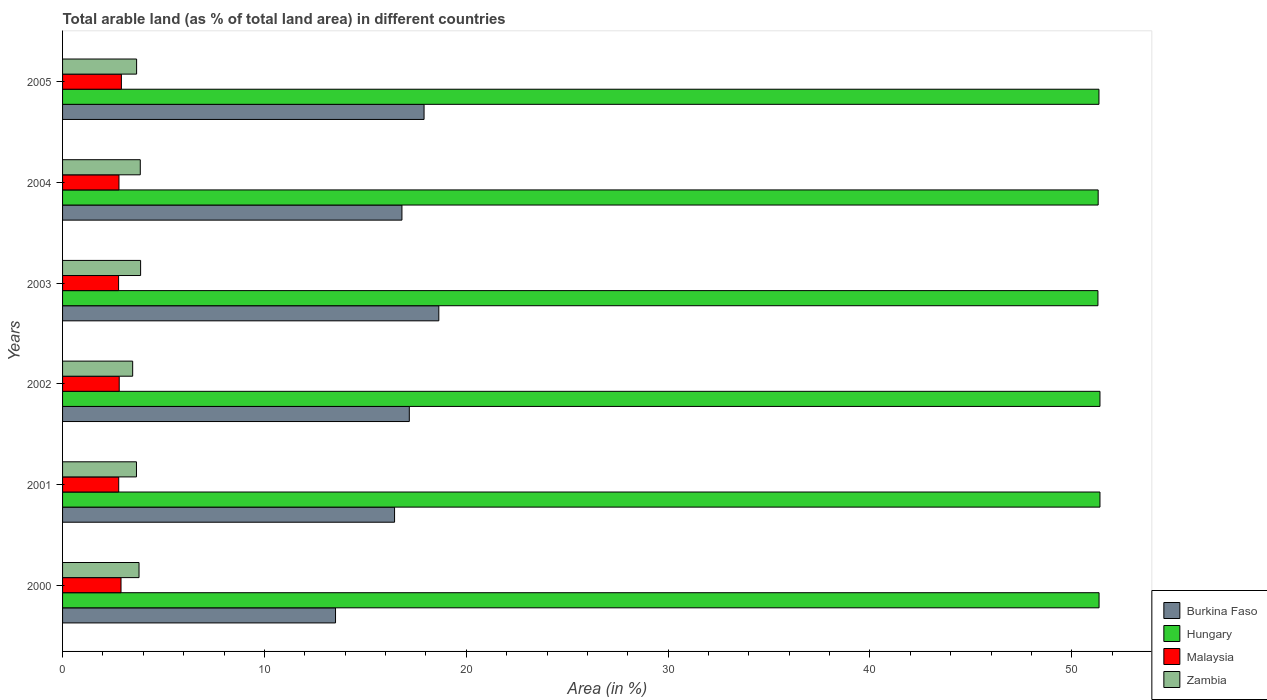How many different coloured bars are there?
Ensure brevity in your answer.  4. Are the number of bars on each tick of the Y-axis equal?
Make the answer very short. Yes. How many bars are there on the 4th tick from the top?
Keep it short and to the point. 4. What is the percentage of arable land in Malaysia in 2003?
Provide a short and direct response. 2.78. Across all years, what is the maximum percentage of arable land in Malaysia?
Keep it short and to the point. 2.91. Across all years, what is the minimum percentage of arable land in Malaysia?
Keep it short and to the point. 2.78. What is the total percentage of arable land in Hungary in the graph?
Offer a very short reply. 308.08. What is the difference between the percentage of arable land in Hungary in 2002 and that in 2004?
Ensure brevity in your answer.  0.09. What is the difference between the percentage of arable land in Malaysia in 2004 and the percentage of arable land in Burkina Faso in 2002?
Offer a very short reply. -14.38. What is the average percentage of arable land in Burkina Faso per year?
Ensure brevity in your answer.  16.75. In the year 2003, what is the difference between the percentage of arable land in Zambia and percentage of arable land in Hungary?
Your answer should be compact. -47.43. In how many years, is the percentage of arable land in Zambia greater than 4 %?
Your response must be concise. 0. What is the ratio of the percentage of arable land in Burkina Faso in 2001 to that in 2002?
Your answer should be very brief. 0.96. Is the percentage of arable land in Zambia in 2003 less than that in 2004?
Your response must be concise. No. Is the difference between the percentage of arable land in Zambia in 2004 and 2005 greater than the difference between the percentage of arable land in Hungary in 2004 and 2005?
Your response must be concise. Yes. What is the difference between the highest and the second highest percentage of arable land in Malaysia?
Make the answer very short. 0.02. What is the difference between the highest and the lowest percentage of arable land in Hungary?
Give a very brief answer. 0.1. In how many years, is the percentage of arable land in Hungary greater than the average percentage of arable land in Hungary taken over all years?
Make the answer very short. 3. Is it the case that in every year, the sum of the percentage of arable land in Malaysia and percentage of arable land in Burkina Faso is greater than the sum of percentage of arable land in Hungary and percentage of arable land in Zambia?
Ensure brevity in your answer.  No. What does the 3rd bar from the top in 2005 represents?
Provide a short and direct response. Hungary. What does the 4th bar from the bottom in 2004 represents?
Ensure brevity in your answer.  Zambia. Is it the case that in every year, the sum of the percentage of arable land in Burkina Faso and percentage of arable land in Hungary is greater than the percentage of arable land in Zambia?
Make the answer very short. Yes. How many bars are there?
Ensure brevity in your answer.  24. Are all the bars in the graph horizontal?
Your answer should be very brief. Yes. Does the graph contain any zero values?
Make the answer very short. No. How many legend labels are there?
Offer a terse response. 4. How are the legend labels stacked?
Offer a very short reply. Vertical. What is the title of the graph?
Offer a terse response. Total arable land (as % of total land area) in different countries. What is the label or title of the X-axis?
Provide a succinct answer. Area (in %). What is the Area (in %) in Burkina Faso in 2000?
Your response must be concise. 13.52. What is the Area (in %) of Hungary in 2000?
Your answer should be very brief. 51.35. What is the Area (in %) of Malaysia in 2000?
Offer a terse response. 2.9. What is the Area (in %) in Zambia in 2000?
Offer a very short reply. 3.79. What is the Area (in %) in Burkina Faso in 2001?
Your response must be concise. 16.45. What is the Area (in %) in Hungary in 2001?
Offer a terse response. 51.39. What is the Area (in %) in Malaysia in 2001?
Offer a very short reply. 2.78. What is the Area (in %) of Zambia in 2001?
Offer a terse response. 3.66. What is the Area (in %) in Burkina Faso in 2002?
Your response must be concise. 17.18. What is the Area (in %) in Hungary in 2002?
Your answer should be compact. 51.39. What is the Area (in %) of Malaysia in 2002?
Provide a succinct answer. 2.81. What is the Area (in %) in Zambia in 2002?
Keep it short and to the point. 3.47. What is the Area (in %) in Burkina Faso in 2003?
Offer a terse response. 18.64. What is the Area (in %) in Hungary in 2003?
Provide a short and direct response. 51.29. What is the Area (in %) of Malaysia in 2003?
Offer a terse response. 2.78. What is the Area (in %) of Zambia in 2003?
Offer a very short reply. 3.87. What is the Area (in %) in Burkina Faso in 2004?
Keep it short and to the point. 16.81. What is the Area (in %) in Hungary in 2004?
Provide a succinct answer. 51.31. What is the Area (in %) of Malaysia in 2004?
Offer a very short reply. 2.79. What is the Area (in %) in Zambia in 2004?
Keep it short and to the point. 3.85. What is the Area (in %) in Burkina Faso in 2005?
Keep it short and to the point. 17.91. What is the Area (in %) of Hungary in 2005?
Keep it short and to the point. 51.34. What is the Area (in %) of Malaysia in 2005?
Keep it short and to the point. 2.91. What is the Area (in %) of Zambia in 2005?
Your response must be concise. 3.67. Across all years, what is the maximum Area (in %) in Burkina Faso?
Provide a short and direct response. 18.64. Across all years, what is the maximum Area (in %) in Hungary?
Keep it short and to the point. 51.39. Across all years, what is the maximum Area (in %) in Malaysia?
Provide a short and direct response. 2.91. Across all years, what is the maximum Area (in %) in Zambia?
Ensure brevity in your answer.  3.87. Across all years, what is the minimum Area (in %) in Burkina Faso?
Make the answer very short. 13.52. Across all years, what is the minimum Area (in %) of Hungary?
Provide a short and direct response. 51.29. Across all years, what is the minimum Area (in %) of Malaysia?
Your answer should be compact. 2.78. Across all years, what is the minimum Area (in %) of Zambia?
Offer a terse response. 3.47. What is the total Area (in %) of Burkina Faso in the graph?
Provide a short and direct response. 100.51. What is the total Area (in %) of Hungary in the graph?
Provide a short and direct response. 308.08. What is the total Area (in %) in Malaysia in the graph?
Offer a very short reply. 16.97. What is the total Area (in %) of Zambia in the graph?
Ensure brevity in your answer.  22.31. What is the difference between the Area (in %) in Burkina Faso in 2000 and that in 2001?
Your response must be concise. -2.92. What is the difference between the Area (in %) of Hungary in 2000 and that in 2001?
Give a very brief answer. -0.04. What is the difference between the Area (in %) in Malaysia in 2000 and that in 2001?
Your answer should be very brief. 0.11. What is the difference between the Area (in %) in Zambia in 2000 and that in 2001?
Your answer should be compact. 0.13. What is the difference between the Area (in %) of Burkina Faso in 2000 and that in 2002?
Your answer should be very brief. -3.65. What is the difference between the Area (in %) of Hungary in 2000 and that in 2002?
Your response must be concise. -0.04. What is the difference between the Area (in %) in Malaysia in 2000 and that in 2002?
Your answer should be very brief. 0.09. What is the difference between the Area (in %) in Zambia in 2000 and that in 2002?
Make the answer very short. 0.31. What is the difference between the Area (in %) in Burkina Faso in 2000 and that in 2003?
Offer a terse response. -5.12. What is the difference between the Area (in %) in Hungary in 2000 and that in 2003?
Provide a short and direct response. 0.06. What is the difference between the Area (in %) of Malaysia in 2000 and that in 2003?
Offer a terse response. 0.12. What is the difference between the Area (in %) in Zambia in 2000 and that in 2003?
Provide a succinct answer. -0.08. What is the difference between the Area (in %) in Burkina Faso in 2000 and that in 2004?
Your response must be concise. -3.29. What is the difference between the Area (in %) of Hungary in 2000 and that in 2004?
Ensure brevity in your answer.  0.04. What is the difference between the Area (in %) in Malaysia in 2000 and that in 2004?
Offer a very short reply. 0.1. What is the difference between the Area (in %) in Zambia in 2000 and that in 2004?
Provide a short and direct response. -0.06. What is the difference between the Area (in %) in Burkina Faso in 2000 and that in 2005?
Keep it short and to the point. -4.39. What is the difference between the Area (in %) of Hungary in 2000 and that in 2005?
Offer a very short reply. 0.01. What is the difference between the Area (in %) in Malaysia in 2000 and that in 2005?
Offer a terse response. -0.02. What is the difference between the Area (in %) in Zambia in 2000 and that in 2005?
Provide a succinct answer. 0.12. What is the difference between the Area (in %) in Burkina Faso in 2001 and that in 2002?
Make the answer very short. -0.73. What is the difference between the Area (in %) in Malaysia in 2001 and that in 2002?
Keep it short and to the point. -0.03. What is the difference between the Area (in %) in Zambia in 2001 and that in 2002?
Provide a short and direct response. 0.19. What is the difference between the Area (in %) in Burkina Faso in 2001 and that in 2003?
Provide a succinct answer. -2.19. What is the difference between the Area (in %) in Hungary in 2001 and that in 2003?
Give a very brief answer. 0.1. What is the difference between the Area (in %) in Malaysia in 2001 and that in 2003?
Your answer should be very brief. 0.01. What is the difference between the Area (in %) in Zambia in 2001 and that in 2003?
Provide a short and direct response. -0.2. What is the difference between the Area (in %) of Burkina Faso in 2001 and that in 2004?
Your response must be concise. -0.37. What is the difference between the Area (in %) of Hungary in 2001 and that in 2004?
Your answer should be very brief. 0.09. What is the difference between the Area (in %) in Malaysia in 2001 and that in 2004?
Make the answer very short. -0.01. What is the difference between the Area (in %) in Zambia in 2001 and that in 2004?
Ensure brevity in your answer.  -0.19. What is the difference between the Area (in %) of Burkina Faso in 2001 and that in 2005?
Offer a terse response. -1.46. What is the difference between the Area (in %) of Hungary in 2001 and that in 2005?
Provide a succinct answer. 0.05. What is the difference between the Area (in %) in Malaysia in 2001 and that in 2005?
Offer a very short reply. -0.13. What is the difference between the Area (in %) in Zambia in 2001 and that in 2005?
Keep it short and to the point. -0.01. What is the difference between the Area (in %) in Burkina Faso in 2002 and that in 2003?
Keep it short and to the point. -1.46. What is the difference between the Area (in %) in Hungary in 2002 and that in 2003?
Ensure brevity in your answer.  0.1. What is the difference between the Area (in %) of Malaysia in 2002 and that in 2003?
Give a very brief answer. 0.03. What is the difference between the Area (in %) of Zambia in 2002 and that in 2003?
Your answer should be very brief. -0.39. What is the difference between the Area (in %) in Burkina Faso in 2002 and that in 2004?
Your response must be concise. 0.37. What is the difference between the Area (in %) of Hungary in 2002 and that in 2004?
Ensure brevity in your answer.  0.09. What is the difference between the Area (in %) in Malaysia in 2002 and that in 2004?
Your response must be concise. 0.01. What is the difference between the Area (in %) in Zambia in 2002 and that in 2004?
Give a very brief answer. -0.38. What is the difference between the Area (in %) of Burkina Faso in 2002 and that in 2005?
Your answer should be compact. -0.73. What is the difference between the Area (in %) of Hungary in 2002 and that in 2005?
Make the answer very short. 0.05. What is the difference between the Area (in %) of Malaysia in 2002 and that in 2005?
Make the answer very short. -0.11. What is the difference between the Area (in %) in Zambia in 2002 and that in 2005?
Offer a very short reply. -0.2. What is the difference between the Area (in %) of Burkina Faso in 2003 and that in 2004?
Your response must be concise. 1.83. What is the difference between the Area (in %) in Hungary in 2003 and that in 2004?
Your answer should be very brief. -0.01. What is the difference between the Area (in %) of Malaysia in 2003 and that in 2004?
Offer a terse response. -0.02. What is the difference between the Area (in %) in Zambia in 2003 and that in 2004?
Keep it short and to the point. 0.02. What is the difference between the Area (in %) of Burkina Faso in 2003 and that in 2005?
Your response must be concise. 0.73. What is the difference between the Area (in %) of Hungary in 2003 and that in 2005?
Provide a short and direct response. -0.05. What is the difference between the Area (in %) of Malaysia in 2003 and that in 2005?
Provide a short and direct response. -0.14. What is the difference between the Area (in %) in Zambia in 2003 and that in 2005?
Your answer should be very brief. 0.2. What is the difference between the Area (in %) in Burkina Faso in 2004 and that in 2005?
Offer a very short reply. -1.1. What is the difference between the Area (in %) in Hungary in 2004 and that in 2005?
Your answer should be very brief. -0.04. What is the difference between the Area (in %) in Malaysia in 2004 and that in 2005?
Offer a very short reply. -0.12. What is the difference between the Area (in %) in Zambia in 2004 and that in 2005?
Make the answer very short. 0.18. What is the difference between the Area (in %) of Burkina Faso in 2000 and the Area (in %) of Hungary in 2001?
Provide a short and direct response. -37.87. What is the difference between the Area (in %) in Burkina Faso in 2000 and the Area (in %) in Malaysia in 2001?
Your answer should be compact. 10.74. What is the difference between the Area (in %) in Burkina Faso in 2000 and the Area (in %) in Zambia in 2001?
Offer a terse response. 9.86. What is the difference between the Area (in %) of Hungary in 2000 and the Area (in %) of Malaysia in 2001?
Give a very brief answer. 48.57. What is the difference between the Area (in %) of Hungary in 2000 and the Area (in %) of Zambia in 2001?
Give a very brief answer. 47.69. What is the difference between the Area (in %) in Malaysia in 2000 and the Area (in %) in Zambia in 2001?
Give a very brief answer. -0.77. What is the difference between the Area (in %) in Burkina Faso in 2000 and the Area (in %) in Hungary in 2002?
Your answer should be very brief. -37.87. What is the difference between the Area (in %) of Burkina Faso in 2000 and the Area (in %) of Malaysia in 2002?
Provide a succinct answer. 10.72. What is the difference between the Area (in %) in Burkina Faso in 2000 and the Area (in %) in Zambia in 2002?
Provide a short and direct response. 10.05. What is the difference between the Area (in %) in Hungary in 2000 and the Area (in %) in Malaysia in 2002?
Your answer should be compact. 48.54. What is the difference between the Area (in %) of Hungary in 2000 and the Area (in %) of Zambia in 2002?
Ensure brevity in your answer.  47.88. What is the difference between the Area (in %) of Malaysia in 2000 and the Area (in %) of Zambia in 2002?
Give a very brief answer. -0.58. What is the difference between the Area (in %) in Burkina Faso in 2000 and the Area (in %) in Hungary in 2003?
Make the answer very short. -37.77. What is the difference between the Area (in %) of Burkina Faso in 2000 and the Area (in %) of Malaysia in 2003?
Give a very brief answer. 10.75. What is the difference between the Area (in %) of Burkina Faso in 2000 and the Area (in %) of Zambia in 2003?
Make the answer very short. 9.66. What is the difference between the Area (in %) of Hungary in 2000 and the Area (in %) of Malaysia in 2003?
Ensure brevity in your answer.  48.57. What is the difference between the Area (in %) in Hungary in 2000 and the Area (in %) in Zambia in 2003?
Your answer should be compact. 47.48. What is the difference between the Area (in %) in Malaysia in 2000 and the Area (in %) in Zambia in 2003?
Provide a short and direct response. -0.97. What is the difference between the Area (in %) of Burkina Faso in 2000 and the Area (in %) of Hungary in 2004?
Provide a short and direct response. -37.78. What is the difference between the Area (in %) of Burkina Faso in 2000 and the Area (in %) of Malaysia in 2004?
Provide a short and direct response. 10.73. What is the difference between the Area (in %) of Burkina Faso in 2000 and the Area (in %) of Zambia in 2004?
Give a very brief answer. 9.67. What is the difference between the Area (in %) of Hungary in 2000 and the Area (in %) of Malaysia in 2004?
Your answer should be very brief. 48.56. What is the difference between the Area (in %) in Hungary in 2000 and the Area (in %) in Zambia in 2004?
Offer a terse response. 47.5. What is the difference between the Area (in %) of Malaysia in 2000 and the Area (in %) of Zambia in 2004?
Your answer should be very brief. -0.95. What is the difference between the Area (in %) of Burkina Faso in 2000 and the Area (in %) of Hungary in 2005?
Make the answer very short. -37.82. What is the difference between the Area (in %) of Burkina Faso in 2000 and the Area (in %) of Malaysia in 2005?
Provide a short and direct response. 10.61. What is the difference between the Area (in %) in Burkina Faso in 2000 and the Area (in %) in Zambia in 2005?
Keep it short and to the point. 9.86. What is the difference between the Area (in %) in Hungary in 2000 and the Area (in %) in Malaysia in 2005?
Provide a short and direct response. 48.44. What is the difference between the Area (in %) of Hungary in 2000 and the Area (in %) of Zambia in 2005?
Your answer should be very brief. 47.68. What is the difference between the Area (in %) in Malaysia in 2000 and the Area (in %) in Zambia in 2005?
Ensure brevity in your answer.  -0.77. What is the difference between the Area (in %) of Burkina Faso in 2001 and the Area (in %) of Hungary in 2002?
Your answer should be compact. -34.95. What is the difference between the Area (in %) in Burkina Faso in 2001 and the Area (in %) in Malaysia in 2002?
Your answer should be very brief. 13.64. What is the difference between the Area (in %) of Burkina Faso in 2001 and the Area (in %) of Zambia in 2002?
Offer a terse response. 12.97. What is the difference between the Area (in %) in Hungary in 2001 and the Area (in %) in Malaysia in 2002?
Provide a short and direct response. 48.59. What is the difference between the Area (in %) of Hungary in 2001 and the Area (in %) of Zambia in 2002?
Offer a very short reply. 47.92. What is the difference between the Area (in %) in Malaysia in 2001 and the Area (in %) in Zambia in 2002?
Your answer should be compact. -0.69. What is the difference between the Area (in %) of Burkina Faso in 2001 and the Area (in %) of Hungary in 2003?
Offer a terse response. -34.85. What is the difference between the Area (in %) in Burkina Faso in 2001 and the Area (in %) in Malaysia in 2003?
Provide a succinct answer. 13.67. What is the difference between the Area (in %) in Burkina Faso in 2001 and the Area (in %) in Zambia in 2003?
Keep it short and to the point. 12.58. What is the difference between the Area (in %) in Hungary in 2001 and the Area (in %) in Malaysia in 2003?
Provide a short and direct response. 48.62. What is the difference between the Area (in %) of Hungary in 2001 and the Area (in %) of Zambia in 2003?
Offer a very short reply. 47.53. What is the difference between the Area (in %) of Malaysia in 2001 and the Area (in %) of Zambia in 2003?
Make the answer very short. -1.08. What is the difference between the Area (in %) in Burkina Faso in 2001 and the Area (in %) in Hungary in 2004?
Offer a very short reply. -34.86. What is the difference between the Area (in %) of Burkina Faso in 2001 and the Area (in %) of Malaysia in 2004?
Keep it short and to the point. 13.65. What is the difference between the Area (in %) of Burkina Faso in 2001 and the Area (in %) of Zambia in 2004?
Your response must be concise. 12.6. What is the difference between the Area (in %) in Hungary in 2001 and the Area (in %) in Malaysia in 2004?
Keep it short and to the point. 48.6. What is the difference between the Area (in %) in Hungary in 2001 and the Area (in %) in Zambia in 2004?
Provide a short and direct response. 47.54. What is the difference between the Area (in %) in Malaysia in 2001 and the Area (in %) in Zambia in 2004?
Make the answer very short. -1.07. What is the difference between the Area (in %) in Burkina Faso in 2001 and the Area (in %) in Hungary in 2005?
Your answer should be compact. -34.9. What is the difference between the Area (in %) of Burkina Faso in 2001 and the Area (in %) of Malaysia in 2005?
Offer a very short reply. 13.53. What is the difference between the Area (in %) of Burkina Faso in 2001 and the Area (in %) of Zambia in 2005?
Offer a terse response. 12.78. What is the difference between the Area (in %) of Hungary in 2001 and the Area (in %) of Malaysia in 2005?
Provide a succinct answer. 48.48. What is the difference between the Area (in %) of Hungary in 2001 and the Area (in %) of Zambia in 2005?
Give a very brief answer. 47.73. What is the difference between the Area (in %) in Malaysia in 2001 and the Area (in %) in Zambia in 2005?
Make the answer very short. -0.89. What is the difference between the Area (in %) in Burkina Faso in 2002 and the Area (in %) in Hungary in 2003?
Provide a succinct answer. -34.12. What is the difference between the Area (in %) in Burkina Faso in 2002 and the Area (in %) in Malaysia in 2003?
Make the answer very short. 14.4. What is the difference between the Area (in %) of Burkina Faso in 2002 and the Area (in %) of Zambia in 2003?
Your response must be concise. 13.31. What is the difference between the Area (in %) of Hungary in 2002 and the Area (in %) of Malaysia in 2003?
Give a very brief answer. 48.62. What is the difference between the Area (in %) in Hungary in 2002 and the Area (in %) in Zambia in 2003?
Provide a succinct answer. 47.53. What is the difference between the Area (in %) of Malaysia in 2002 and the Area (in %) of Zambia in 2003?
Provide a succinct answer. -1.06. What is the difference between the Area (in %) of Burkina Faso in 2002 and the Area (in %) of Hungary in 2004?
Give a very brief answer. -34.13. What is the difference between the Area (in %) of Burkina Faso in 2002 and the Area (in %) of Malaysia in 2004?
Keep it short and to the point. 14.38. What is the difference between the Area (in %) in Burkina Faso in 2002 and the Area (in %) in Zambia in 2004?
Give a very brief answer. 13.33. What is the difference between the Area (in %) of Hungary in 2002 and the Area (in %) of Malaysia in 2004?
Offer a terse response. 48.6. What is the difference between the Area (in %) in Hungary in 2002 and the Area (in %) in Zambia in 2004?
Give a very brief answer. 47.54. What is the difference between the Area (in %) in Malaysia in 2002 and the Area (in %) in Zambia in 2004?
Give a very brief answer. -1.04. What is the difference between the Area (in %) of Burkina Faso in 2002 and the Area (in %) of Hungary in 2005?
Your answer should be compact. -34.17. What is the difference between the Area (in %) of Burkina Faso in 2002 and the Area (in %) of Malaysia in 2005?
Offer a very short reply. 14.26. What is the difference between the Area (in %) of Burkina Faso in 2002 and the Area (in %) of Zambia in 2005?
Your answer should be compact. 13.51. What is the difference between the Area (in %) of Hungary in 2002 and the Area (in %) of Malaysia in 2005?
Ensure brevity in your answer.  48.48. What is the difference between the Area (in %) in Hungary in 2002 and the Area (in %) in Zambia in 2005?
Your answer should be compact. 47.73. What is the difference between the Area (in %) in Malaysia in 2002 and the Area (in %) in Zambia in 2005?
Make the answer very short. -0.86. What is the difference between the Area (in %) in Burkina Faso in 2003 and the Area (in %) in Hungary in 2004?
Provide a succinct answer. -32.67. What is the difference between the Area (in %) in Burkina Faso in 2003 and the Area (in %) in Malaysia in 2004?
Your response must be concise. 15.85. What is the difference between the Area (in %) in Burkina Faso in 2003 and the Area (in %) in Zambia in 2004?
Make the answer very short. 14.79. What is the difference between the Area (in %) in Hungary in 2003 and the Area (in %) in Malaysia in 2004?
Make the answer very short. 48.5. What is the difference between the Area (in %) in Hungary in 2003 and the Area (in %) in Zambia in 2004?
Provide a short and direct response. 47.44. What is the difference between the Area (in %) of Malaysia in 2003 and the Area (in %) of Zambia in 2004?
Offer a very short reply. -1.07. What is the difference between the Area (in %) of Burkina Faso in 2003 and the Area (in %) of Hungary in 2005?
Provide a short and direct response. -32.7. What is the difference between the Area (in %) of Burkina Faso in 2003 and the Area (in %) of Malaysia in 2005?
Offer a very short reply. 15.73. What is the difference between the Area (in %) in Burkina Faso in 2003 and the Area (in %) in Zambia in 2005?
Provide a succinct answer. 14.97. What is the difference between the Area (in %) in Hungary in 2003 and the Area (in %) in Malaysia in 2005?
Offer a terse response. 48.38. What is the difference between the Area (in %) of Hungary in 2003 and the Area (in %) of Zambia in 2005?
Your answer should be very brief. 47.63. What is the difference between the Area (in %) of Malaysia in 2003 and the Area (in %) of Zambia in 2005?
Keep it short and to the point. -0.89. What is the difference between the Area (in %) in Burkina Faso in 2004 and the Area (in %) in Hungary in 2005?
Keep it short and to the point. -34.53. What is the difference between the Area (in %) of Burkina Faso in 2004 and the Area (in %) of Malaysia in 2005?
Offer a terse response. 13.9. What is the difference between the Area (in %) of Burkina Faso in 2004 and the Area (in %) of Zambia in 2005?
Make the answer very short. 13.14. What is the difference between the Area (in %) in Hungary in 2004 and the Area (in %) in Malaysia in 2005?
Make the answer very short. 48.39. What is the difference between the Area (in %) of Hungary in 2004 and the Area (in %) of Zambia in 2005?
Offer a very short reply. 47.64. What is the difference between the Area (in %) in Malaysia in 2004 and the Area (in %) in Zambia in 2005?
Offer a very short reply. -0.87. What is the average Area (in %) of Burkina Faso per year?
Give a very brief answer. 16.75. What is the average Area (in %) in Hungary per year?
Your answer should be very brief. 51.35. What is the average Area (in %) in Malaysia per year?
Ensure brevity in your answer.  2.83. What is the average Area (in %) in Zambia per year?
Provide a succinct answer. 3.72. In the year 2000, what is the difference between the Area (in %) of Burkina Faso and Area (in %) of Hungary?
Keep it short and to the point. -37.83. In the year 2000, what is the difference between the Area (in %) of Burkina Faso and Area (in %) of Malaysia?
Give a very brief answer. 10.63. In the year 2000, what is the difference between the Area (in %) in Burkina Faso and Area (in %) in Zambia?
Your answer should be compact. 9.74. In the year 2000, what is the difference between the Area (in %) in Hungary and Area (in %) in Malaysia?
Provide a succinct answer. 48.45. In the year 2000, what is the difference between the Area (in %) of Hungary and Area (in %) of Zambia?
Give a very brief answer. 47.56. In the year 2000, what is the difference between the Area (in %) in Malaysia and Area (in %) in Zambia?
Provide a short and direct response. -0.89. In the year 2001, what is the difference between the Area (in %) in Burkina Faso and Area (in %) in Hungary?
Ensure brevity in your answer.  -34.95. In the year 2001, what is the difference between the Area (in %) in Burkina Faso and Area (in %) in Malaysia?
Your response must be concise. 13.67. In the year 2001, what is the difference between the Area (in %) of Burkina Faso and Area (in %) of Zambia?
Offer a terse response. 12.79. In the year 2001, what is the difference between the Area (in %) in Hungary and Area (in %) in Malaysia?
Offer a very short reply. 48.61. In the year 2001, what is the difference between the Area (in %) of Hungary and Area (in %) of Zambia?
Your answer should be compact. 47.73. In the year 2001, what is the difference between the Area (in %) of Malaysia and Area (in %) of Zambia?
Your response must be concise. -0.88. In the year 2002, what is the difference between the Area (in %) of Burkina Faso and Area (in %) of Hungary?
Keep it short and to the point. -34.22. In the year 2002, what is the difference between the Area (in %) in Burkina Faso and Area (in %) in Malaysia?
Give a very brief answer. 14.37. In the year 2002, what is the difference between the Area (in %) in Burkina Faso and Area (in %) in Zambia?
Ensure brevity in your answer.  13.71. In the year 2002, what is the difference between the Area (in %) in Hungary and Area (in %) in Malaysia?
Offer a very short reply. 48.59. In the year 2002, what is the difference between the Area (in %) of Hungary and Area (in %) of Zambia?
Provide a succinct answer. 47.92. In the year 2002, what is the difference between the Area (in %) of Malaysia and Area (in %) of Zambia?
Offer a very short reply. -0.67. In the year 2003, what is the difference between the Area (in %) of Burkina Faso and Area (in %) of Hungary?
Keep it short and to the point. -32.65. In the year 2003, what is the difference between the Area (in %) of Burkina Faso and Area (in %) of Malaysia?
Ensure brevity in your answer.  15.86. In the year 2003, what is the difference between the Area (in %) in Burkina Faso and Area (in %) in Zambia?
Your response must be concise. 14.77. In the year 2003, what is the difference between the Area (in %) of Hungary and Area (in %) of Malaysia?
Keep it short and to the point. 48.52. In the year 2003, what is the difference between the Area (in %) of Hungary and Area (in %) of Zambia?
Your response must be concise. 47.43. In the year 2003, what is the difference between the Area (in %) in Malaysia and Area (in %) in Zambia?
Your answer should be compact. -1.09. In the year 2004, what is the difference between the Area (in %) in Burkina Faso and Area (in %) in Hungary?
Ensure brevity in your answer.  -34.49. In the year 2004, what is the difference between the Area (in %) of Burkina Faso and Area (in %) of Malaysia?
Provide a succinct answer. 14.02. In the year 2004, what is the difference between the Area (in %) of Burkina Faso and Area (in %) of Zambia?
Provide a short and direct response. 12.96. In the year 2004, what is the difference between the Area (in %) in Hungary and Area (in %) in Malaysia?
Offer a terse response. 48.51. In the year 2004, what is the difference between the Area (in %) in Hungary and Area (in %) in Zambia?
Keep it short and to the point. 47.46. In the year 2004, what is the difference between the Area (in %) of Malaysia and Area (in %) of Zambia?
Provide a succinct answer. -1.06. In the year 2005, what is the difference between the Area (in %) of Burkina Faso and Area (in %) of Hungary?
Your answer should be very brief. -33.44. In the year 2005, what is the difference between the Area (in %) of Burkina Faso and Area (in %) of Malaysia?
Ensure brevity in your answer.  14.99. In the year 2005, what is the difference between the Area (in %) in Burkina Faso and Area (in %) in Zambia?
Offer a terse response. 14.24. In the year 2005, what is the difference between the Area (in %) in Hungary and Area (in %) in Malaysia?
Keep it short and to the point. 48.43. In the year 2005, what is the difference between the Area (in %) of Hungary and Area (in %) of Zambia?
Your response must be concise. 47.68. In the year 2005, what is the difference between the Area (in %) in Malaysia and Area (in %) in Zambia?
Your answer should be compact. -0.75. What is the ratio of the Area (in %) of Burkina Faso in 2000 to that in 2001?
Your response must be concise. 0.82. What is the ratio of the Area (in %) in Hungary in 2000 to that in 2001?
Offer a terse response. 1. What is the ratio of the Area (in %) in Malaysia in 2000 to that in 2001?
Keep it short and to the point. 1.04. What is the ratio of the Area (in %) of Zambia in 2000 to that in 2001?
Provide a succinct answer. 1.03. What is the ratio of the Area (in %) of Burkina Faso in 2000 to that in 2002?
Provide a succinct answer. 0.79. What is the ratio of the Area (in %) in Malaysia in 2000 to that in 2002?
Your response must be concise. 1.03. What is the ratio of the Area (in %) in Zambia in 2000 to that in 2002?
Your answer should be very brief. 1.09. What is the ratio of the Area (in %) of Burkina Faso in 2000 to that in 2003?
Give a very brief answer. 0.73. What is the ratio of the Area (in %) of Malaysia in 2000 to that in 2003?
Keep it short and to the point. 1.04. What is the ratio of the Area (in %) of Zambia in 2000 to that in 2003?
Make the answer very short. 0.98. What is the ratio of the Area (in %) in Burkina Faso in 2000 to that in 2004?
Make the answer very short. 0.8. What is the ratio of the Area (in %) in Malaysia in 2000 to that in 2004?
Your response must be concise. 1.04. What is the ratio of the Area (in %) of Zambia in 2000 to that in 2004?
Make the answer very short. 0.98. What is the ratio of the Area (in %) of Burkina Faso in 2000 to that in 2005?
Your response must be concise. 0.76. What is the ratio of the Area (in %) of Zambia in 2000 to that in 2005?
Make the answer very short. 1.03. What is the ratio of the Area (in %) in Burkina Faso in 2001 to that in 2002?
Provide a succinct answer. 0.96. What is the ratio of the Area (in %) in Hungary in 2001 to that in 2002?
Your answer should be compact. 1. What is the ratio of the Area (in %) in Malaysia in 2001 to that in 2002?
Make the answer very short. 0.99. What is the ratio of the Area (in %) in Zambia in 2001 to that in 2002?
Provide a succinct answer. 1.05. What is the ratio of the Area (in %) in Burkina Faso in 2001 to that in 2003?
Your answer should be compact. 0.88. What is the ratio of the Area (in %) in Hungary in 2001 to that in 2003?
Ensure brevity in your answer.  1. What is the ratio of the Area (in %) of Malaysia in 2001 to that in 2003?
Your answer should be compact. 1. What is the ratio of the Area (in %) in Zambia in 2001 to that in 2003?
Your answer should be compact. 0.95. What is the ratio of the Area (in %) in Burkina Faso in 2001 to that in 2004?
Your response must be concise. 0.98. What is the ratio of the Area (in %) of Hungary in 2001 to that in 2004?
Your response must be concise. 1. What is the ratio of the Area (in %) of Zambia in 2001 to that in 2004?
Keep it short and to the point. 0.95. What is the ratio of the Area (in %) in Burkina Faso in 2001 to that in 2005?
Offer a very short reply. 0.92. What is the ratio of the Area (in %) of Hungary in 2001 to that in 2005?
Offer a very short reply. 1. What is the ratio of the Area (in %) of Malaysia in 2001 to that in 2005?
Offer a very short reply. 0.95. What is the ratio of the Area (in %) of Burkina Faso in 2002 to that in 2003?
Your response must be concise. 0.92. What is the ratio of the Area (in %) of Malaysia in 2002 to that in 2003?
Your answer should be compact. 1.01. What is the ratio of the Area (in %) of Zambia in 2002 to that in 2003?
Offer a terse response. 0.9. What is the ratio of the Area (in %) in Burkina Faso in 2002 to that in 2004?
Your response must be concise. 1.02. What is the ratio of the Area (in %) of Hungary in 2002 to that in 2004?
Give a very brief answer. 1. What is the ratio of the Area (in %) of Malaysia in 2002 to that in 2004?
Your answer should be compact. 1. What is the ratio of the Area (in %) of Zambia in 2002 to that in 2004?
Your response must be concise. 0.9. What is the ratio of the Area (in %) of Burkina Faso in 2002 to that in 2005?
Ensure brevity in your answer.  0.96. What is the ratio of the Area (in %) of Hungary in 2002 to that in 2005?
Your answer should be compact. 1. What is the ratio of the Area (in %) in Malaysia in 2002 to that in 2005?
Make the answer very short. 0.96. What is the ratio of the Area (in %) of Zambia in 2002 to that in 2005?
Provide a short and direct response. 0.95. What is the ratio of the Area (in %) of Burkina Faso in 2003 to that in 2004?
Your response must be concise. 1.11. What is the ratio of the Area (in %) in Hungary in 2003 to that in 2004?
Make the answer very short. 1. What is the ratio of the Area (in %) of Burkina Faso in 2003 to that in 2005?
Provide a short and direct response. 1.04. What is the ratio of the Area (in %) of Malaysia in 2003 to that in 2005?
Your answer should be very brief. 0.95. What is the ratio of the Area (in %) in Zambia in 2003 to that in 2005?
Your answer should be compact. 1.05. What is the ratio of the Area (in %) of Burkina Faso in 2004 to that in 2005?
Make the answer very short. 0.94. What is the ratio of the Area (in %) of Hungary in 2004 to that in 2005?
Your answer should be compact. 1. What is the ratio of the Area (in %) of Malaysia in 2004 to that in 2005?
Offer a terse response. 0.96. What is the ratio of the Area (in %) of Zambia in 2004 to that in 2005?
Provide a succinct answer. 1.05. What is the difference between the highest and the second highest Area (in %) in Burkina Faso?
Your response must be concise. 0.73. What is the difference between the highest and the second highest Area (in %) of Malaysia?
Provide a succinct answer. 0.02. What is the difference between the highest and the second highest Area (in %) of Zambia?
Provide a succinct answer. 0.02. What is the difference between the highest and the lowest Area (in %) in Burkina Faso?
Provide a succinct answer. 5.12. What is the difference between the highest and the lowest Area (in %) in Hungary?
Your response must be concise. 0.1. What is the difference between the highest and the lowest Area (in %) in Malaysia?
Give a very brief answer. 0.14. What is the difference between the highest and the lowest Area (in %) of Zambia?
Make the answer very short. 0.39. 